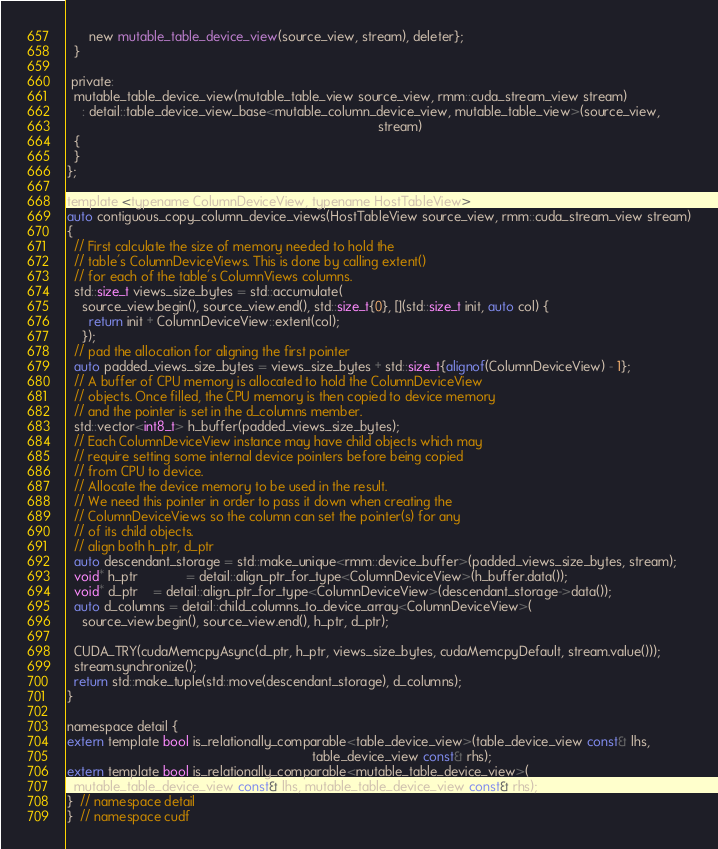<code> <loc_0><loc_0><loc_500><loc_500><_Cuda_>      new mutable_table_device_view(source_view, stream), deleter};
  }

 private:
  mutable_table_device_view(mutable_table_view source_view, rmm::cuda_stream_view stream)
    : detail::table_device_view_base<mutable_column_device_view, mutable_table_view>(source_view,
                                                                                     stream)
  {
  }
};

template <typename ColumnDeviceView, typename HostTableView>
auto contiguous_copy_column_device_views(HostTableView source_view, rmm::cuda_stream_view stream)
{
  // First calculate the size of memory needed to hold the
  // table's ColumnDeviceViews. This is done by calling extent()
  // for each of the table's ColumnViews columns.
  std::size_t views_size_bytes = std::accumulate(
    source_view.begin(), source_view.end(), std::size_t{0}, [](std::size_t init, auto col) {
      return init + ColumnDeviceView::extent(col);
    });
  // pad the allocation for aligning the first pointer
  auto padded_views_size_bytes = views_size_bytes + std::size_t{alignof(ColumnDeviceView) - 1};
  // A buffer of CPU memory is allocated to hold the ColumnDeviceView
  // objects. Once filled, the CPU memory is then copied to device memory
  // and the pointer is set in the d_columns member.
  std::vector<int8_t> h_buffer(padded_views_size_bytes);
  // Each ColumnDeviceView instance may have child objects which may
  // require setting some internal device pointers before being copied
  // from CPU to device.
  // Allocate the device memory to be used in the result.
  // We need this pointer in order to pass it down when creating the
  // ColumnDeviceViews so the column can set the pointer(s) for any
  // of its child objects.
  // align both h_ptr, d_ptr
  auto descendant_storage = std::make_unique<rmm::device_buffer>(padded_views_size_bytes, stream);
  void* h_ptr             = detail::align_ptr_for_type<ColumnDeviceView>(h_buffer.data());
  void* d_ptr    = detail::align_ptr_for_type<ColumnDeviceView>(descendant_storage->data());
  auto d_columns = detail::child_columns_to_device_array<ColumnDeviceView>(
    source_view.begin(), source_view.end(), h_ptr, d_ptr);

  CUDA_TRY(cudaMemcpyAsync(d_ptr, h_ptr, views_size_bytes, cudaMemcpyDefault, stream.value()));
  stream.synchronize();
  return std::make_tuple(std::move(descendant_storage), d_columns);
}

namespace detail {
extern template bool is_relationally_comparable<table_device_view>(table_device_view const& lhs,
                                                                   table_device_view const& rhs);
extern template bool is_relationally_comparable<mutable_table_device_view>(
  mutable_table_device_view const& lhs, mutable_table_device_view const& rhs);
}  // namespace detail
}  // namespace cudf
</code> 